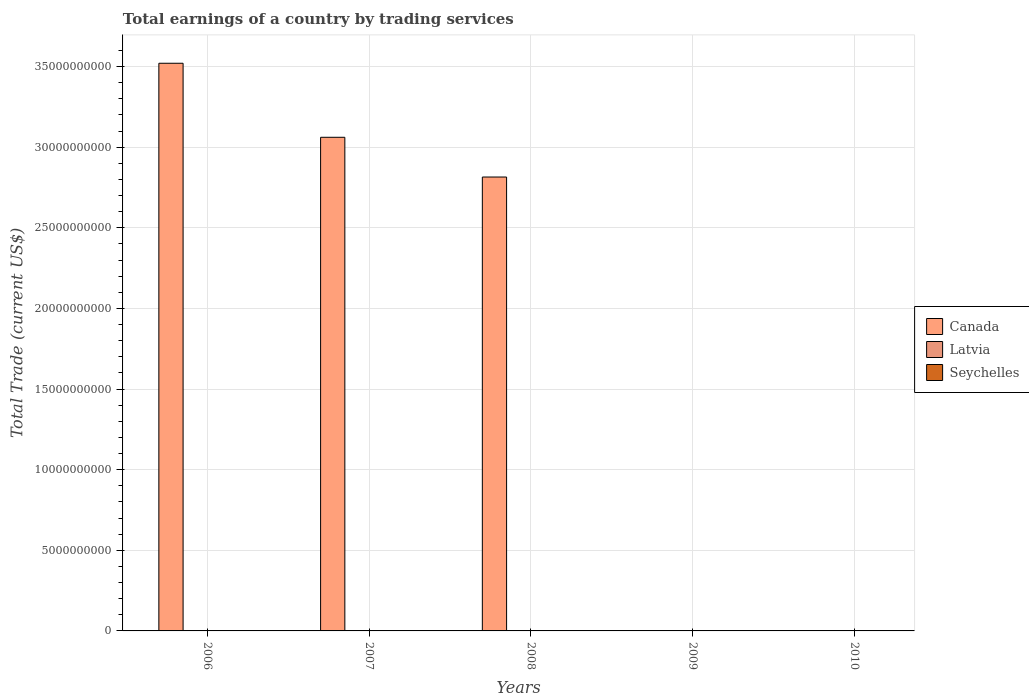Are the number of bars on each tick of the X-axis equal?
Provide a short and direct response. No. How many bars are there on the 2nd tick from the left?
Provide a short and direct response. 1. How many bars are there on the 1st tick from the right?
Offer a terse response. 0. What is the total earnings in Seychelles in 2006?
Ensure brevity in your answer.  0. What is the total total earnings in Latvia in the graph?
Provide a short and direct response. 0. What is the difference between the total earnings in Canada in 2007 and that in 2008?
Keep it short and to the point. 2.46e+09. What is the difference between the total earnings in Latvia in 2008 and the total earnings in Seychelles in 2007?
Provide a succinct answer. 0. In how many years, is the total earnings in Latvia greater than 16000000000 US$?
Offer a terse response. 0. What is the difference between the highest and the second highest total earnings in Canada?
Your answer should be compact. 4.59e+09. What is the difference between the highest and the lowest total earnings in Canada?
Provide a succinct answer. 3.52e+1. What is the difference between two consecutive major ticks on the Y-axis?
Offer a terse response. 5.00e+09. Are the values on the major ticks of Y-axis written in scientific E-notation?
Provide a short and direct response. No. How are the legend labels stacked?
Provide a succinct answer. Vertical. What is the title of the graph?
Keep it short and to the point. Total earnings of a country by trading services. What is the label or title of the X-axis?
Provide a short and direct response. Years. What is the label or title of the Y-axis?
Your answer should be compact. Total Trade (current US$). What is the Total Trade (current US$) in Canada in 2006?
Give a very brief answer. 3.52e+1. What is the Total Trade (current US$) in Canada in 2007?
Your answer should be compact. 3.06e+1. What is the Total Trade (current US$) in Canada in 2008?
Your answer should be very brief. 2.81e+1. What is the Total Trade (current US$) in Latvia in 2008?
Make the answer very short. 0. What is the Total Trade (current US$) in Seychelles in 2008?
Keep it short and to the point. 0. What is the Total Trade (current US$) of Latvia in 2009?
Provide a succinct answer. 0. What is the Total Trade (current US$) in Canada in 2010?
Offer a very short reply. 0. Across all years, what is the maximum Total Trade (current US$) of Canada?
Your answer should be compact. 3.52e+1. Across all years, what is the minimum Total Trade (current US$) of Canada?
Ensure brevity in your answer.  0. What is the total Total Trade (current US$) in Canada in the graph?
Your answer should be compact. 9.40e+1. What is the total Total Trade (current US$) of Latvia in the graph?
Offer a terse response. 0. What is the total Total Trade (current US$) in Seychelles in the graph?
Give a very brief answer. 0. What is the difference between the Total Trade (current US$) in Canada in 2006 and that in 2007?
Offer a very short reply. 4.59e+09. What is the difference between the Total Trade (current US$) of Canada in 2006 and that in 2008?
Your response must be concise. 7.05e+09. What is the difference between the Total Trade (current US$) in Canada in 2007 and that in 2008?
Make the answer very short. 2.46e+09. What is the average Total Trade (current US$) of Canada per year?
Give a very brief answer. 1.88e+1. What is the average Total Trade (current US$) of Latvia per year?
Offer a terse response. 0. What is the average Total Trade (current US$) in Seychelles per year?
Your answer should be very brief. 0. What is the ratio of the Total Trade (current US$) in Canada in 2006 to that in 2007?
Ensure brevity in your answer.  1.15. What is the ratio of the Total Trade (current US$) in Canada in 2006 to that in 2008?
Ensure brevity in your answer.  1.25. What is the ratio of the Total Trade (current US$) in Canada in 2007 to that in 2008?
Offer a very short reply. 1.09. What is the difference between the highest and the second highest Total Trade (current US$) of Canada?
Provide a succinct answer. 4.59e+09. What is the difference between the highest and the lowest Total Trade (current US$) in Canada?
Your response must be concise. 3.52e+1. 